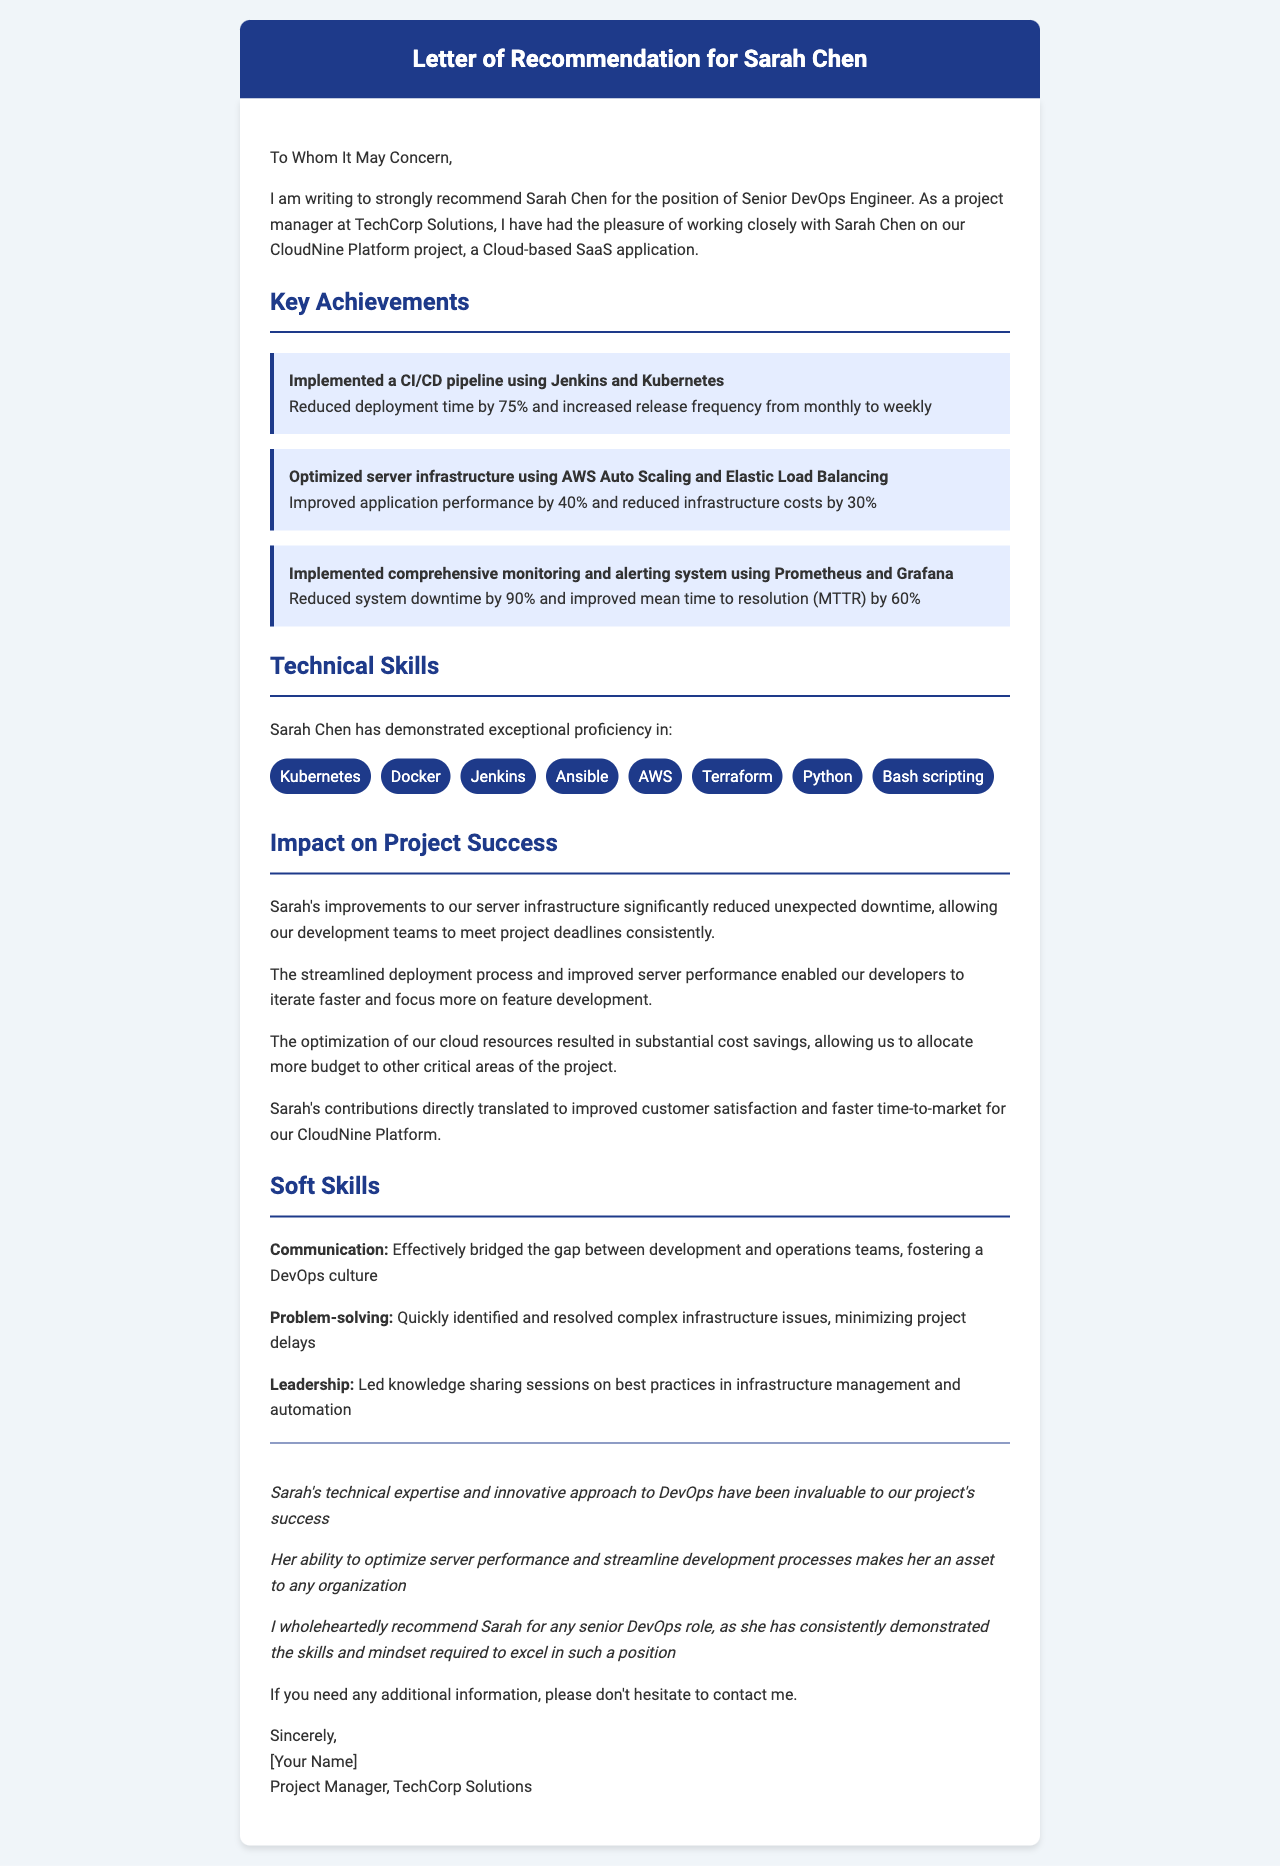What is the name of the DevOps engineer? The name of the DevOps engineer is mentioned at the beginning of the letter.
Answer: Sarah Chen What is the position recommended for Sarah Chen? The letter states the position Sarah Chen is being recommended for.
Answer: Senior DevOps Engineer How many years of experience does Sarah Chen have? Sarah Chen's experience is stated in the introductory part of the document.
Answer: 5 years What is one key achievement related to server optimization? One of the key achievements refers to the improvement of application performance due to server optimizations.
Answer: Improved application performance by 40% What technical skill is used for implementing CI/CD pipelines? The document lists technical skills relevant to Sarah's role, including the technology used for CI/CD pipelines.
Answer: Jenkins How did Sarah contribute to reducing system downtime? The impact of one of Sarah's achievements directly relates to system downtime reduction.
Answer: Reduced system downtime by 90% What is a soft skill highlighted in the letter? The letter explicitly states several soft skills; one is specifically pointed out along with an example.
Answer: Communication What was the impact of Sarah's work on customer satisfaction? The document mentions a direct relationship between Sarah's contributions and business outcomes.
Answer: Improved customer satisfaction What kind of document is this? The purpose of the document is stated in the introductory part.
Answer: Letter of Recommendation 